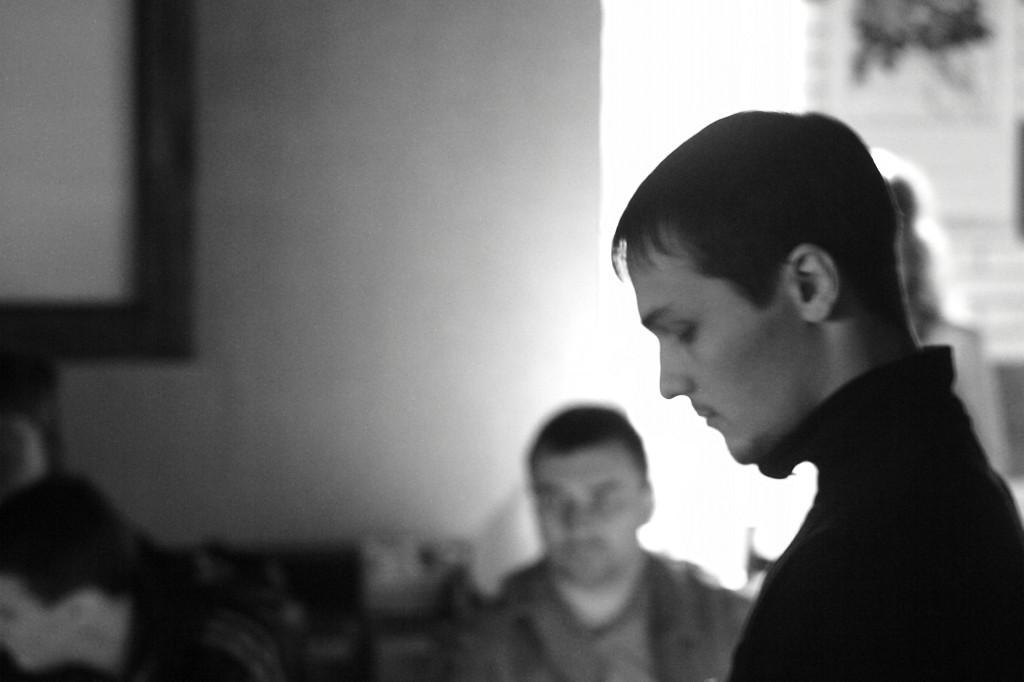What is the color scheme of the image? The image is black and white. How many people are in the image? There are two persons in the image. What is the person wearing on the left side of the image wearing? The person on the left side of the image is wearing a black dress. How is the person in the black dress described? The person in the black dress is described as stunning. What can be seen in the background of the image? There is a photo frame in the background of the image. What type of berry can be seen in the image? There is no berry present in the image. How does the stunning person in the black dress maintain their quiet demeanor in the image? The image does not provide information about the person's demeanor or any sounds, so it cannot be determined from the image. 